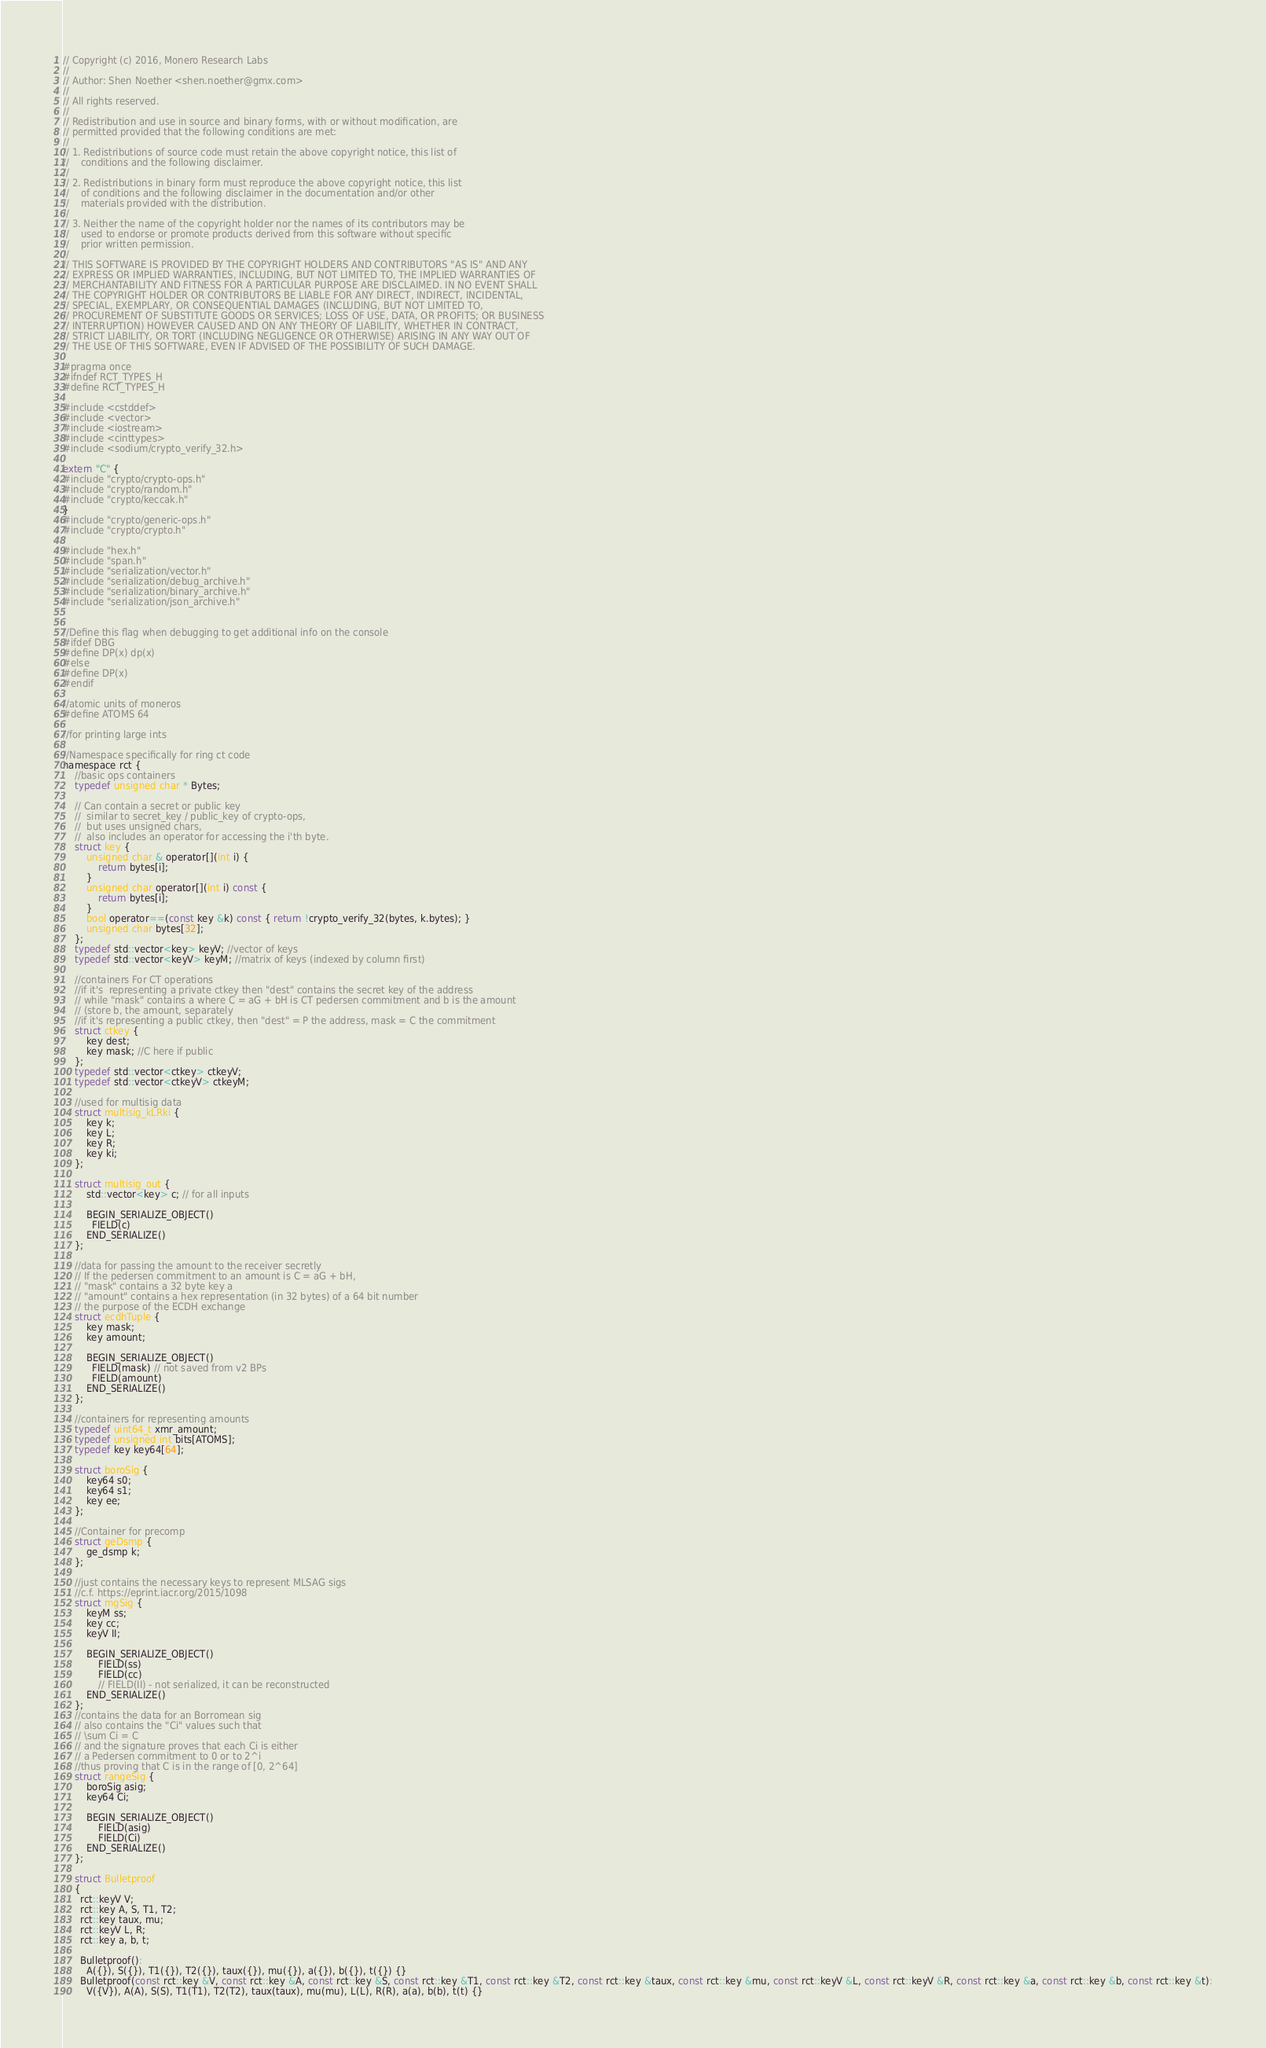<code> <loc_0><loc_0><loc_500><loc_500><_C_>// Copyright (c) 2016, Monero Research Labs
//
// Author: Shen Noether <shen.noether@gmx.com>
//
// All rights reserved.
//
// Redistribution and use in source and binary forms, with or without modification, are
// permitted provided that the following conditions are met:
//
// 1. Redistributions of source code must retain the above copyright notice, this list of
//    conditions and the following disclaimer.
//
// 2. Redistributions in binary form must reproduce the above copyright notice, this list
//    of conditions and the following disclaimer in the documentation and/or other
//    materials provided with the distribution.
//
// 3. Neither the name of the copyright holder nor the names of its contributors may be
//    used to endorse or promote products derived from this software without specific
//    prior written permission.
//
// THIS SOFTWARE IS PROVIDED BY THE COPYRIGHT HOLDERS AND CONTRIBUTORS "AS IS" AND ANY
// EXPRESS OR IMPLIED WARRANTIES, INCLUDING, BUT NOT LIMITED TO, THE IMPLIED WARRANTIES OF
// MERCHANTABILITY AND FITNESS FOR A PARTICULAR PURPOSE ARE DISCLAIMED. IN NO EVENT SHALL
// THE COPYRIGHT HOLDER OR CONTRIBUTORS BE LIABLE FOR ANY DIRECT, INDIRECT, INCIDENTAL,
// SPECIAL, EXEMPLARY, OR CONSEQUENTIAL DAMAGES (INCLUDING, BUT NOT LIMITED TO,
// PROCUREMENT OF SUBSTITUTE GOODS OR SERVICES; LOSS OF USE, DATA, OR PROFITS; OR BUSINESS
// INTERRUPTION) HOWEVER CAUSED AND ON ANY THEORY OF LIABILITY, WHETHER IN CONTRACT,
// STRICT LIABILITY, OR TORT (INCLUDING NEGLIGENCE OR OTHERWISE) ARISING IN ANY WAY OUT OF
// THE USE OF THIS SOFTWARE, EVEN IF ADVISED OF THE POSSIBILITY OF SUCH DAMAGE.

#pragma once
#ifndef RCT_TYPES_H
#define RCT_TYPES_H

#include <cstddef>
#include <vector>
#include <iostream>
#include <cinttypes>
#include <sodium/crypto_verify_32.h>

extern "C" {
#include "crypto/crypto-ops.h"
#include "crypto/random.h"
#include "crypto/keccak.h"
}
#include "crypto/generic-ops.h"
#include "crypto/crypto.h"

#include "hex.h"
#include "span.h"
#include "serialization/vector.h"
#include "serialization/debug_archive.h"
#include "serialization/binary_archive.h"
#include "serialization/json_archive.h"


//Define this flag when debugging to get additional info on the console
#ifdef DBG
#define DP(x) dp(x)
#else
#define DP(x)
#endif

//atomic units of moneros
#define ATOMS 64

//for printing large ints

//Namespace specifically for ring ct code
namespace rct {
    //basic ops containers
    typedef unsigned char * Bytes;

    // Can contain a secret or public key
    //  similar to secret_key / public_key of crypto-ops,
    //  but uses unsigned chars,
    //  also includes an operator for accessing the i'th byte.
    struct key {
        unsigned char & operator[](int i) {
            return bytes[i];
        }
        unsigned char operator[](int i) const {
            return bytes[i];
        }
        bool operator==(const key &k) const { return !crypto_verify_32(bytes, k.bytes); }
        unsigned char bytes[32];
    };
    typedef std::vector<key> keyV; //vector of keys
    typedef std::vector<keyV> keyM; //matrix of keys (indexed by column first)

    //containers For CT operations
    //if it's  representing a private ctkey then "dest" contains the secret key of the address
    // while "mask" contains a where C = aG + bH is CT pedersen commitment and b is the amount
    // (store b, the amount, separately
    //if it's representing a public ctkey, then "dest" = P the address, mask = C the commitment
    struct ctkey {
        key dest;
        key mask; //C here if public
    };
    typedef std::vector<ctkey> ctkeyV;
    typedef std::vector<ctkeyV> ctkeyM;

    //used for multisig data
    struct multisig_kLRki {
        key k;
        key L;
        key R;
        key ki;
    };

    struct multisig_out {
        std::vector<key> c; // for all inputs

        BEGIN_SERIALIZE_OBJECT()
          FIELD(c)
        END_SERIALIZE()
    };

    //data for passing the amount to the receiver secretly
    // If the pedersen commitment to an amount is C = aG + bH,
    // "mask" contains a 32 byte key a
    // "amount" contains a hex representation (in 32 bytes) of a 64 bit number
    // the purpose of the ECDH exchange
    struct ecdhTuple {
        key mask;
        key amount;

        BEGIN_SERIALIZE_OBJECT()
          FIELD(mask) // not saved from v2 BPs
          FIELD(amount)
        END_SERIALIZE()
    };

    //containers for representing amounts
    typedef uint64_t xmr_amount;
    typedef unsigned int bits[ATOMS];
    typedef key key64[64];

    struct boroSig {
        key64 s0;
        key64 s1;
        key ee;
    };
  
    //Container for precomp
    struct geDsmp {
        ge_dsmp k;
    };
    
    //just contains the necessary keys to represent MLSAG sigs
    //c.f. https://eprint.iacr.org/2015/1098
    struct mgSig {
        keyM ss;
        key cc;
        keyV II;

        BEGIN_SERIALIZE_OBJECT()
            FIELD(ss)
            FIELD(cc)
            // FIELD(II) - not serialized, it can be reconstructed
        END_SERIALIZE()
    };
    //contains the data for an Borromean sig
    // also contains the "Ci" values such that
    // \sum Ci = C
    // and the signature proves that each Ci is either
    // a Pedersen commitment to 0 or to 2^i
    //thus proving that C is in the range of [0, 2^64]
    struct rangeSig {
        boroSig asig;
        key64 Ci;

        BEGIN_SERIALIZE_OBJECT()
            FIELD(asig)
            FIELD(Ci)
        END_SERIALIZE()
    };

    struct Bulletproof
    {
      rct::keyV V;
      rct::key A, S, T1, T2;
      rct::key taux, mu;
      rct::keyV L, R;
      rct::key a, b, t;

      Bulletproof():
        A({}), S({}), T1({}), T2({}), taux({}), mu({}), a({}), b({}), t({}) {}
      Bulletproof(const rct::key &V, const rct::key &A, const rct::key &S, const rct::key &T1, const rct::key &T2, const rct::key &taux, const rct::key &mu, const rct::keyV &L, const rct::keyV &R, const rct::key &a, const rct::key &b, const rct::key &t):
        V({V}), A(A), S(S), T1(T1), T2(T2), taux(taux), mu(mu), L(L), R(R), a(a), b(b), t(t) {}</code> 